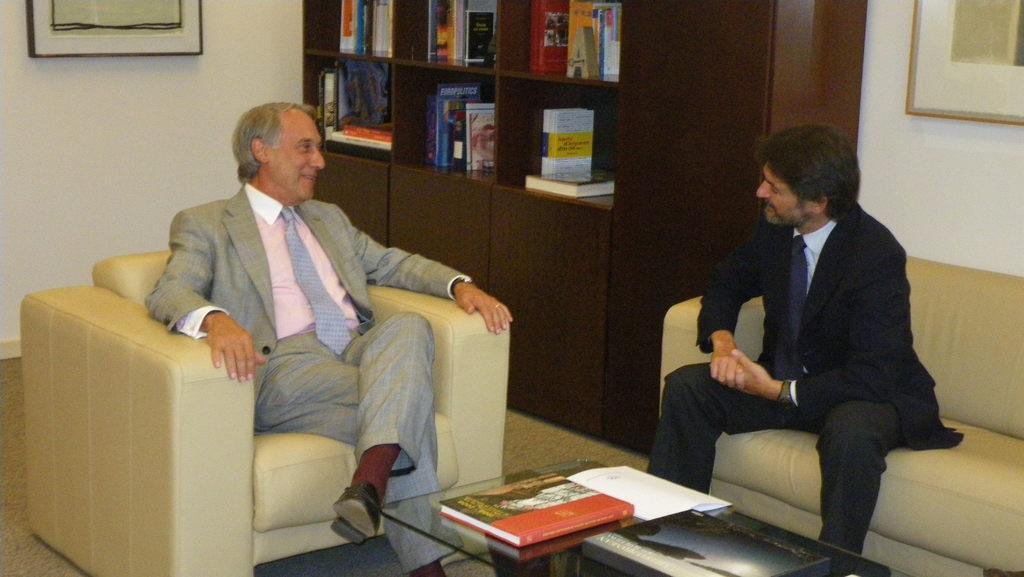How would you summarize this image in a sentence or two? In this image, we can see two peoples in suit they sat on the chair and sofa. There is a table at the bottom, few items are placed on it. At back side, we can see bookshelf. Right side and left side, we can see some photo frames and walls. 